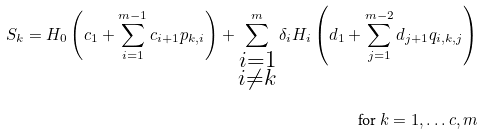<formula> <loc_0><loc_0><loc_500><loc_500>S _ { k } = H _ { 0 } \left ( c _ { 1 } + \sum _ { i = 1 } ^ { m - 1 } c _ { i + 1 } p _ { k , i } \right ) + \sum _ { \substack { i = 1 \\ i \ne k } } ^ { m } \delta _ { i } H _ { i } \left ( d _ { 1 } + \sum _ { j = 1 } ^ { m - 2 } d _ { j + 1 } q _ { i , k , j } \right ) \\ \quad \text {for } k = 1 , \dots c , m</formula> 